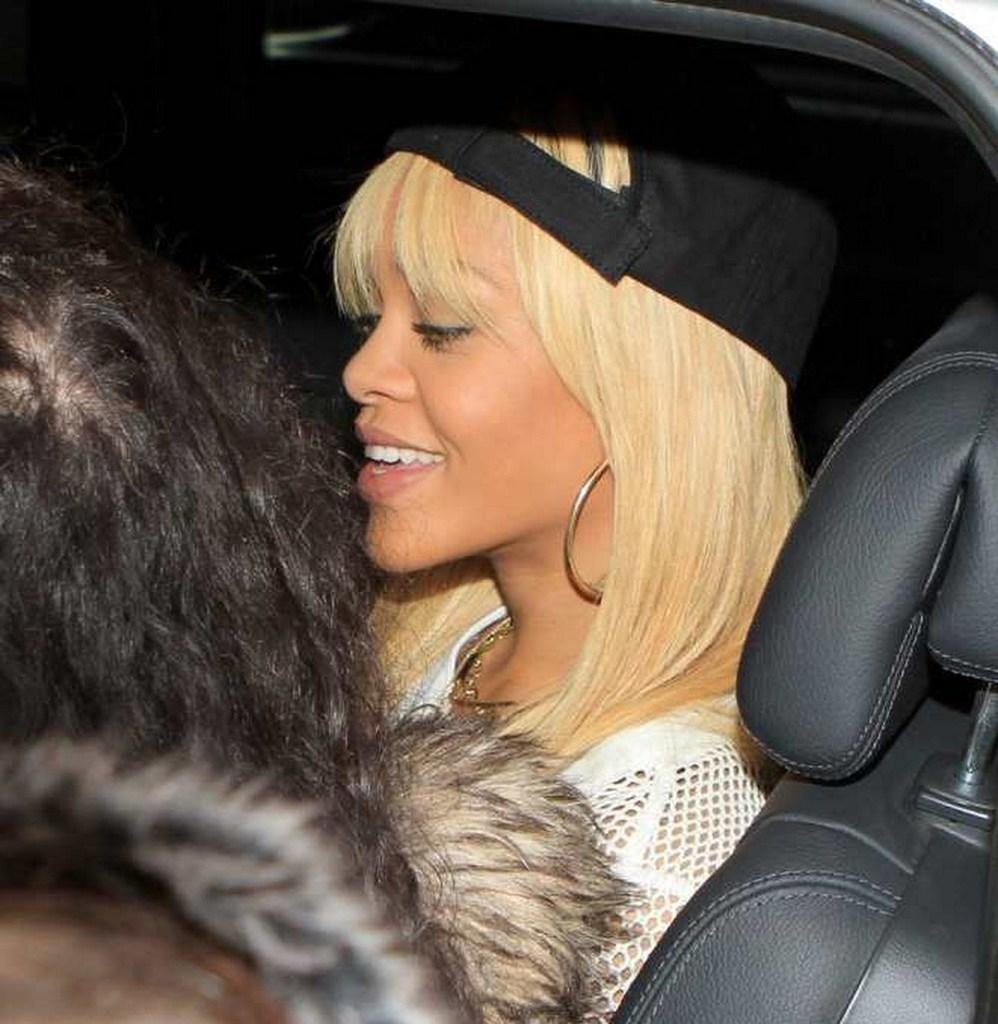Who is present in the image? There is a woman in the image. What is the woman wearing on her head? The woman is wearing a black hat. Where is the woman sitting in the image? The woman is sitting in a car. Is there anyone else in the car with the woman? Yes, there is another person sitting beside the woman in the car. What color is the paint on the nest in the image? There is no paint or nest present in the image; it features a woman sitting in a car with another person. 